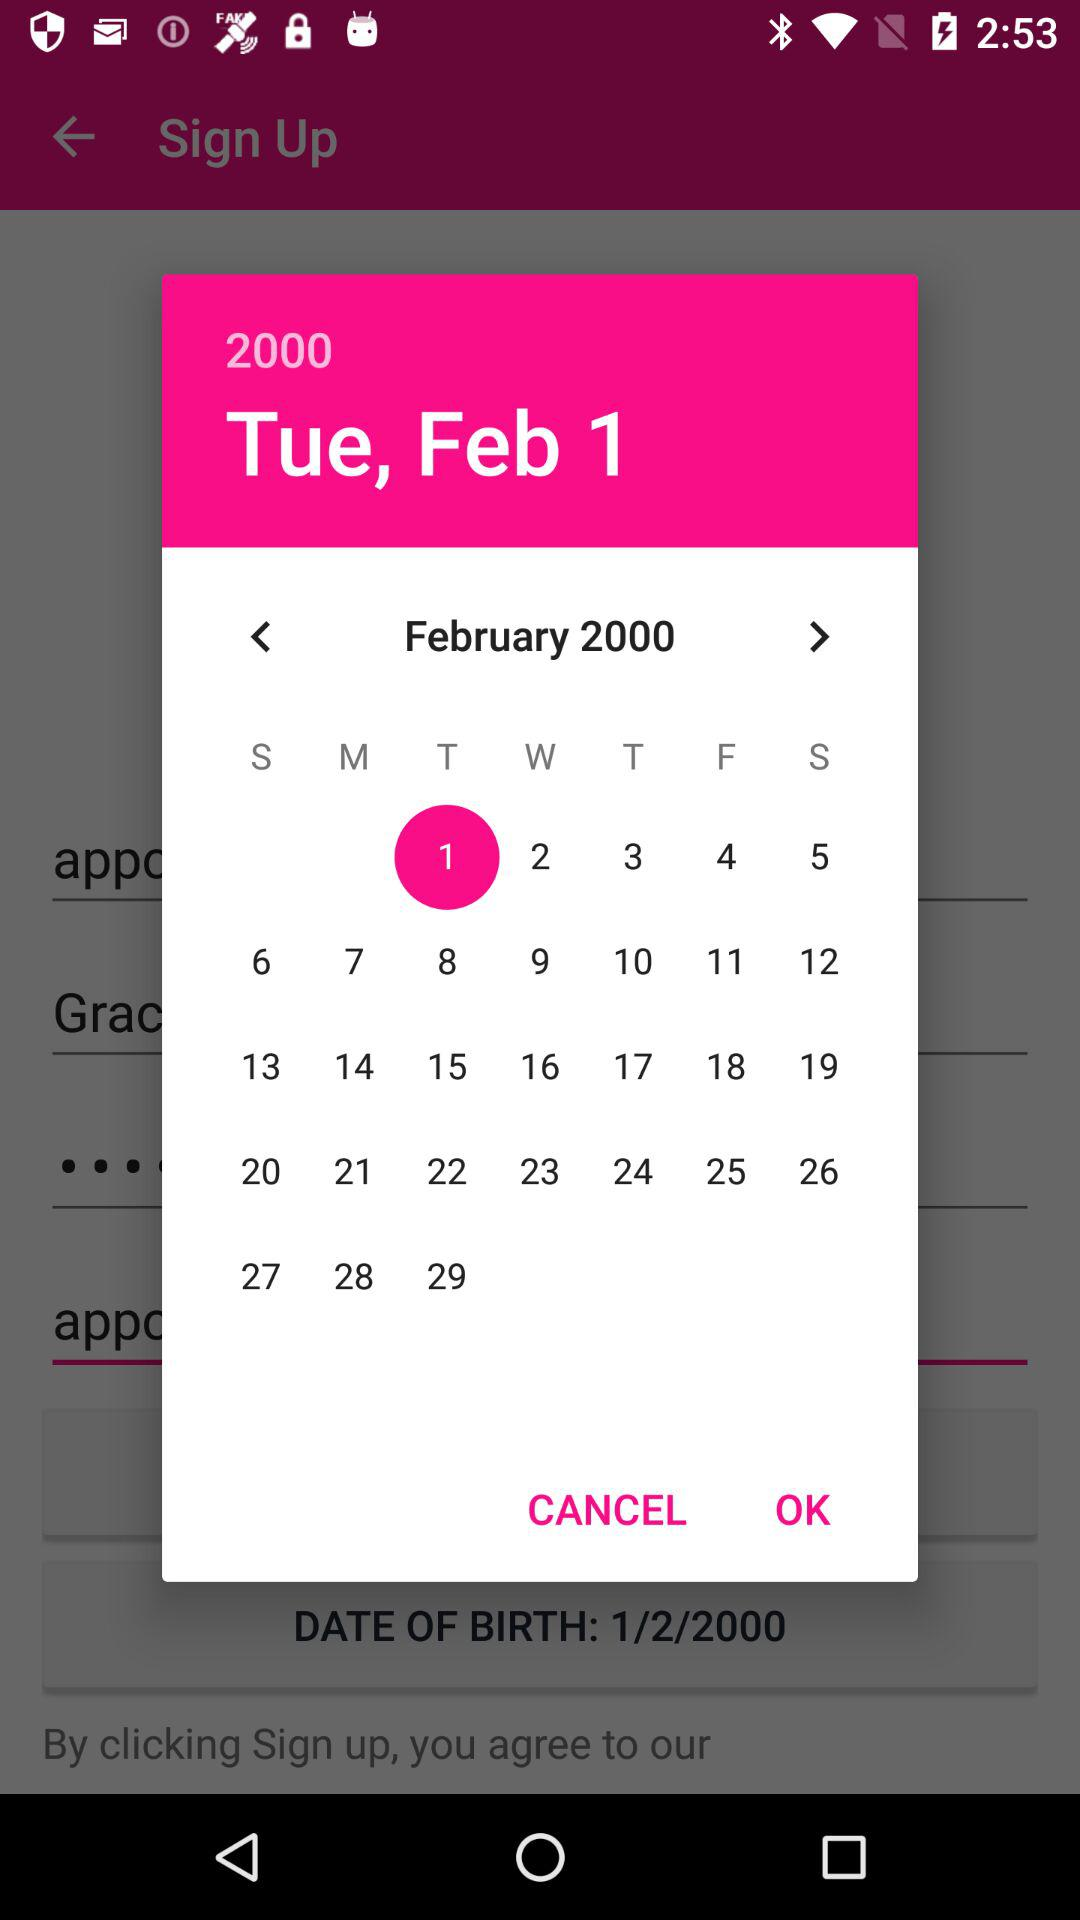Which date is selected on the screen? The selected date is Tuesday, February 1, 2000. 